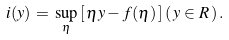Convert formula to latex. <formula><loc_0><loc_0><loc_500><loc_500>i ( y ) \, = \, \sup _ { \eta } \, [ \, \eta y - f ( \eta ) \, ] \, ( \, y \in R \, ) \, .</formula> 